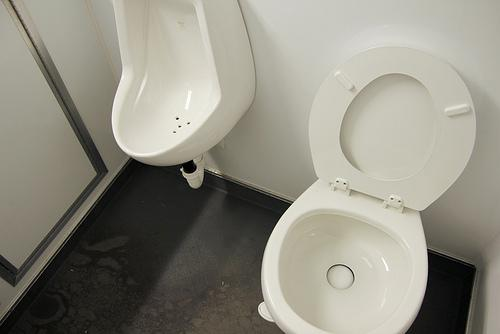Question: what color is the walls?
Choices:
A. Grey.
B. Brown.
C. White.
D. Green.
Answer with the letter. Answer: C Question: who is in the bathroom?
Choices:
A. No one.
B. Homeowner.
C. Guest.
D. Man.
Answer with the letter. Answer: A Question: what is the right item called?
Choices:
A. Sink.
B. A toilet.
C. Tub.
D. Bidet.
Answer with the letter. Answer: B Question: what is the left item called?
Choices:
A. Soap dispenser.
B. Paper-towel dispenser.
C. Hand dryer.
D. A urinal.
Answer with the letter. Answer: D Question: how many items in the picture are used for the bathroom?
Choices:
A. 3.
B. 1.
C. 2.
D. 4.
Answer with the letter. Answer: C Question: where is this picture taken?
Choices:
A. Den.
B. Patio.
C. Kitchen.
D. Bathroom.
Answer with the letter. Answer: D 